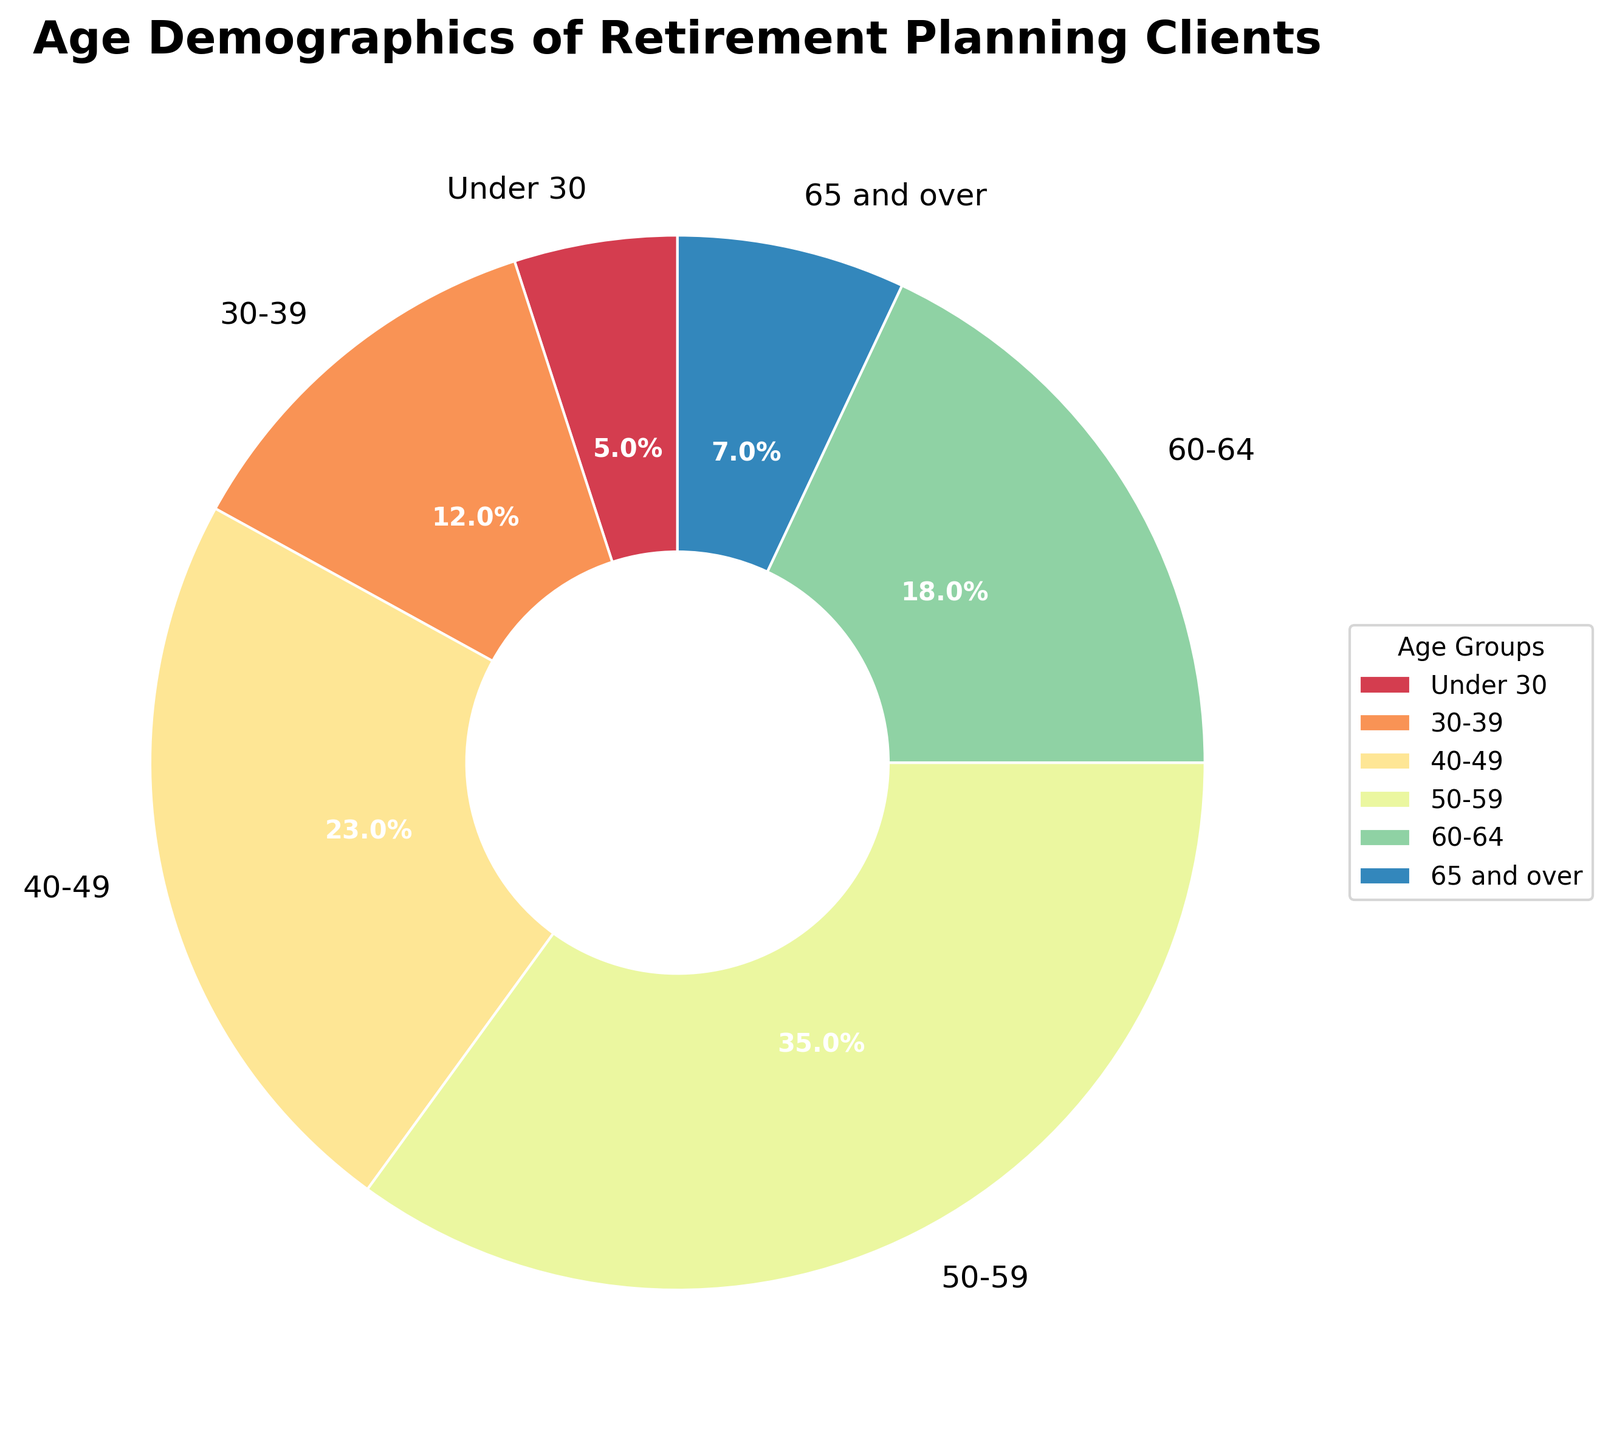What's the largest age group among the retirement planning clients? By looking at the pie chart, identify the age group with the largest percentage label. The "50-59" age group takes up the largest portion with 35%.
Answer: 50-59 What's the combined percentage of clients under 50 years old? Sum the percentages of the age groups "Under 30", "30-39", and "40-49", which are 5%, 12%, and 23%, respectively. So, 5 + 12 + 23 = 40.
Answer: 40% Which age group has the smallest representation in the client base? Identify the age group with the smallest percentage label in the pie chart. "Under 30" is the smallest with 5%.
Answer: Under 30 What is the difference in representation between the 50-59 age group and the 40-49 age group? Subtract the percentage of the "40-49" group from the "50-59" group, which is 35% - 23% = 12%.
Answer: 12% How many age groups have more than 20% of the clients? Count the segments with percentages greater than 20% from the pie chart. The age groups "40-49" and "50-59" fit this criterion, so 2 groups.
Answer: 2 If we group all clients aged 60 and above, what is their total percentage? Sum the percentages of "60-64" and "65 and over", which are 18% and 7%, respectively. So, 18 + 7 = 25%.
Answer: 25% What is the ratio of clients in the "50-59" group compared to those in the "60-64" group? Divide the percentage of the "50-59" group by the "60-64" group, which is 35% / 18% ≈ 1.94.
Answer: 1.94 Which wedge in the pie chart is represented by a color closer to purple? Identify the color according to the visual spectrum used in the plot. In the "Spectral" colormap, "60-64" and "30-39" are closer to purple, with "60-64" hue being more prominent.
Answer: 60-64 